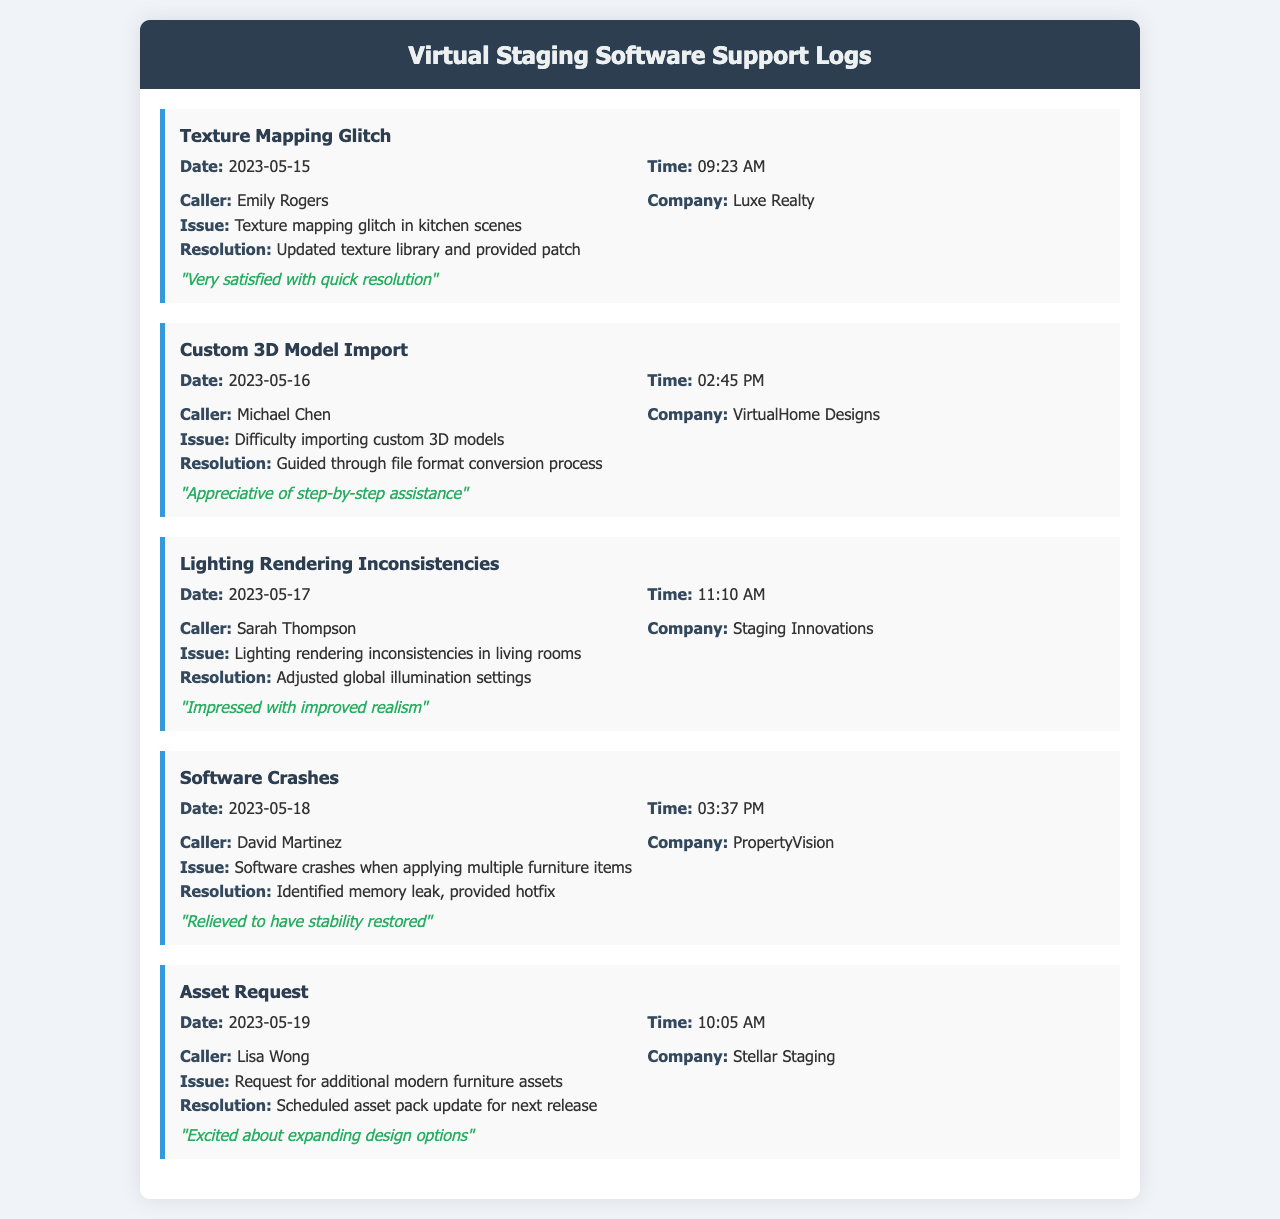what was the issue reported by Emily Rogers? The issue reported by Emily Rogers was a texture mapping glitch in kitchen scenes.
Answer: Texture mapping glitch in kitchen scenes who called on May 18, 2023? The caller on May 18, 2023, was David Martinez.
Answer: David Martinez what resolution was provided for the lighting rendering inconsistencies? The resolution provided was adjusting the global illumination settings.
Answer: Adjusted global illumination settings which company requested additional furniture assets? The company that requested additional furniture assets was Stellar Staging.
Answer: Stellar Staging how many calls were logged on May 16, 2023? One call was logged on May 16, 2023.
Answer: One what was Michael Chen's feedback on the support received? Michael Chen appreciated the step-by-step assistance.
Answer: Appreciative of step-by-step assistance what problem did David Martinez face with the software? David Martinez faced software crashes when applying multiple furniture items.
Answer: Software crashes when applying multiple furniture items when did Lisa Wong make her asset request? Lisa Wong made her asset request on May 19, 2023.
Answer: May 19, 2023 what was the feedback from Sarah Thompson about the support? Sarah Thompson was impressed with the improved realism.
Answer: Impressed with improved realism 